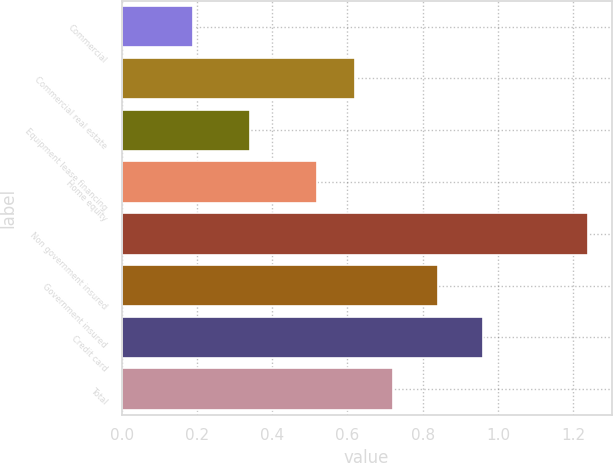Convert chart. <chart><loc_0><loc_0><loc_500><loc_500><bar_chart><fcel>Commercial<fcel>Commercial real estate<fcel>Equipment lease financing<fcel>Home equity<fcel>Non government insured<fcel>Government insured<fcel>Credit card<fcel>Total<nl><fcel>0.19<fcel>0.62<fcel>0.34<fcel>0.52<fcel>1.24<fcel>0.84<fcel>0.96<fcel>0.72<nl></chart> 